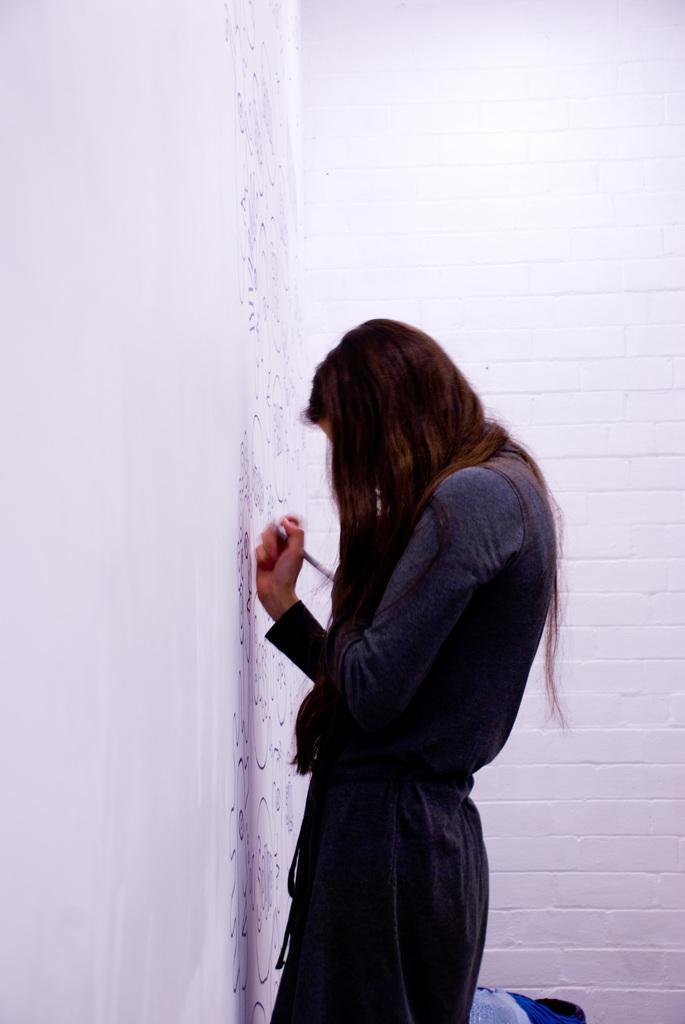Could you give a brief overview of what you see in this image? In the center of the image there is a woman standing at wall holding a pen. In the background there is a wall. 